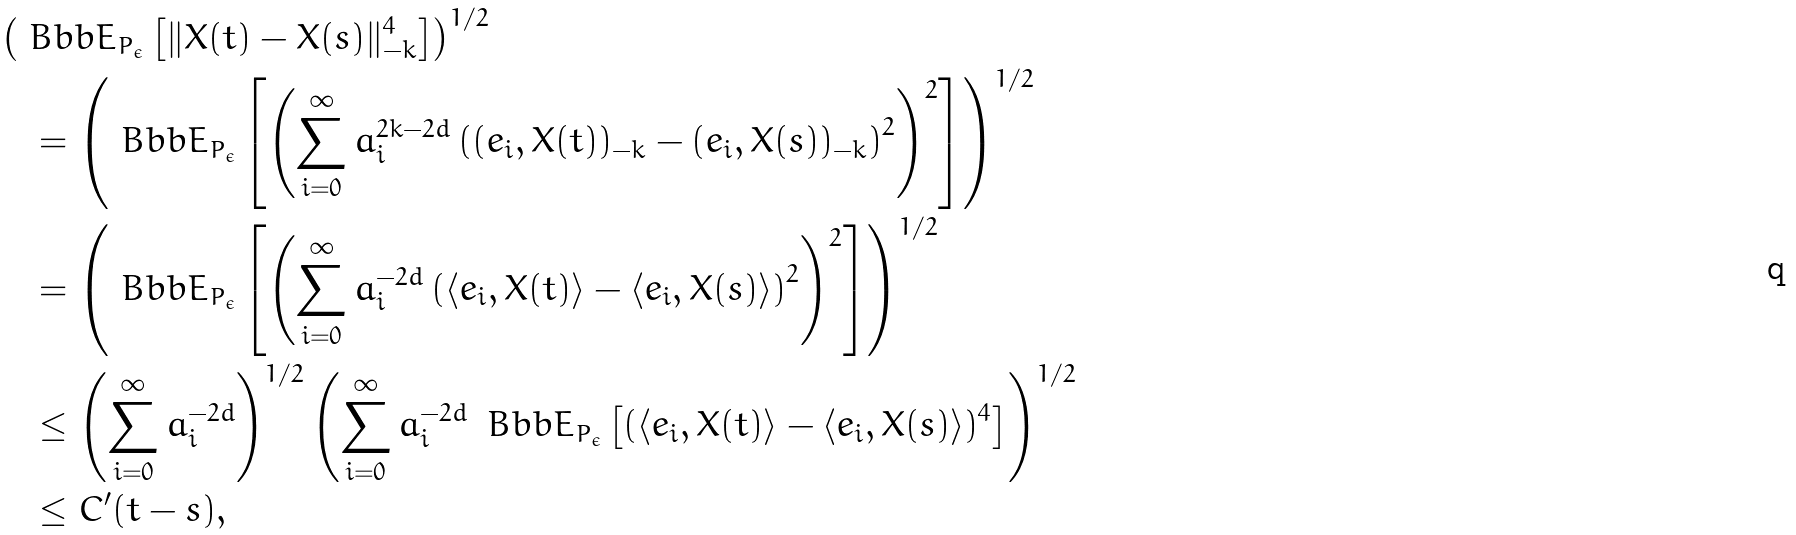Convert formula to latex. <formula><loc_0><loc_0><loc_500><loc_500>& \left ( { \ B b b E } _ { { P } _ { \epsilon } } \left [ \| { X } ( t ) - { X } ( s ) \| _ { - k } ^ { 4 } \right ] \right ) ^ { 1 / 2 } \\ & \quad = \left ( { \ B b b E } _ { { P } _ { \epsilon } } \left [ \left ( \sum _ { i = 0 } ^ { \infty } a _ { i } ^ { 2 k - 2 d } \left ( ( e _ { i } , { X } ( t ) ) _ { - k } - ( e _ { i } , { X } ( s ) ) _ { - k } \right ) ^ { 2 } \right ) ^ { 2 } \right ] \right ) ^ { 1 / 2 } \\ & \quad = \left ( { \ B b b E } _ { { P } _ { \epsilon } } \left [ \left ( \sum _ { i = 0 } ^ { \infty } a _ { i } ^ { - 2 d } \left ( \langle e _ { i } , { X } ( t ) \rangle - \langle e _ { i } , { X } ( s ) \rangle \right ) ^ { 2 } \right ) ^ { 2 } \right ] \right ) ^ { 1 / 2 } \\ & \quad \leq \left ( \sum _ { i = 0 } ^ { \infty } a _ { i } ^ { - 2 d } \right ) ^ { 1 / 2 } \left ( \sum _ { i = 0 } ^ { \infty } a _ { i } ^ { - 2 d } \, { \ B b b E } _ { { P } _ { \epsilon } } \left [ ( \langle e _ { i } , { X } ( t ) \rangle - \langle e _ { i } , { X } ( s ) \rangle ) ^ { 4 } \right ] \right ) ^ { 1 / 2 } \\ & \quad \leq C ^ { \prime } ( t - s ) ,</formula> 